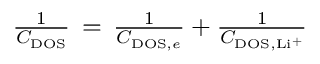Convert formula to latex. <formula><loc_0><loc_0><loc_500><loc_500>\begin{array} { r } { \frac { 1 } { C _ { D O S } } \, = \, \frac { 1 } { C _ { D O S , e } } + \frac { 1 } { C _ { D O S , L i ^ { + } } } } \end{array}</formula> 